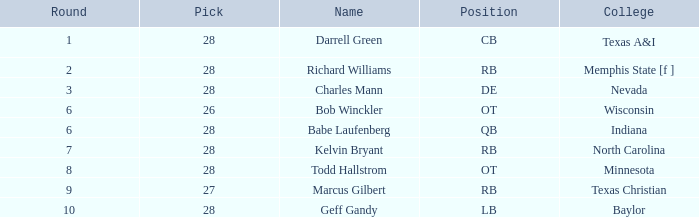What is the highest pick of the player from texas a&i with an overall less than 28? None. 